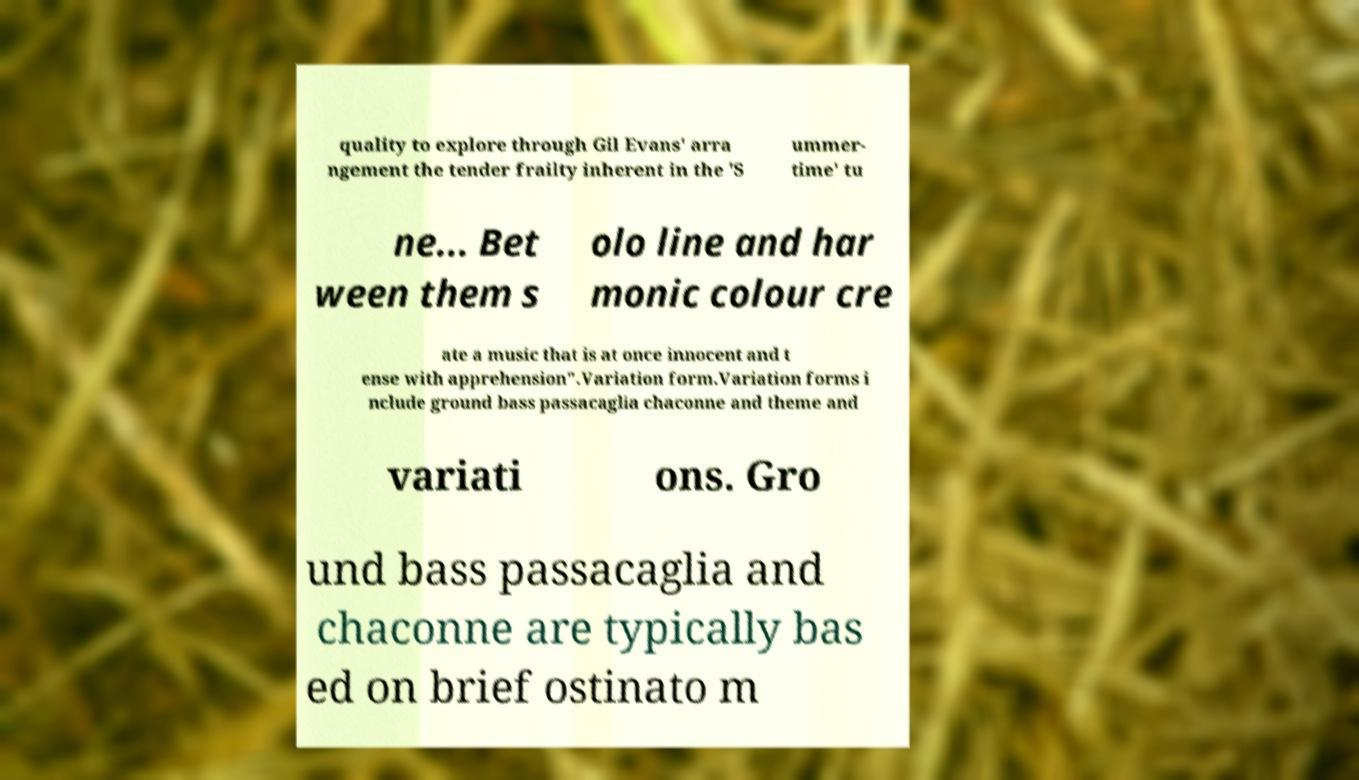Can you read and provide the text displayed in the image?This photo seems to have some interesting text. Can you extract and type it out for me? quality to explore through Gil Evans' arra ngement the tender frailty inherent in the 'S ummer- time' tu ne... Bet ween them s olo line and har monic colour cre ate a music that is at once innocent and t ense with apprehension".Variation form.Variation forms i nclude ground bass passacaglia chaconne and theme and variati ons. Gro und bass passacaglia and chaconne are typically bas ed on brief ostinato m 